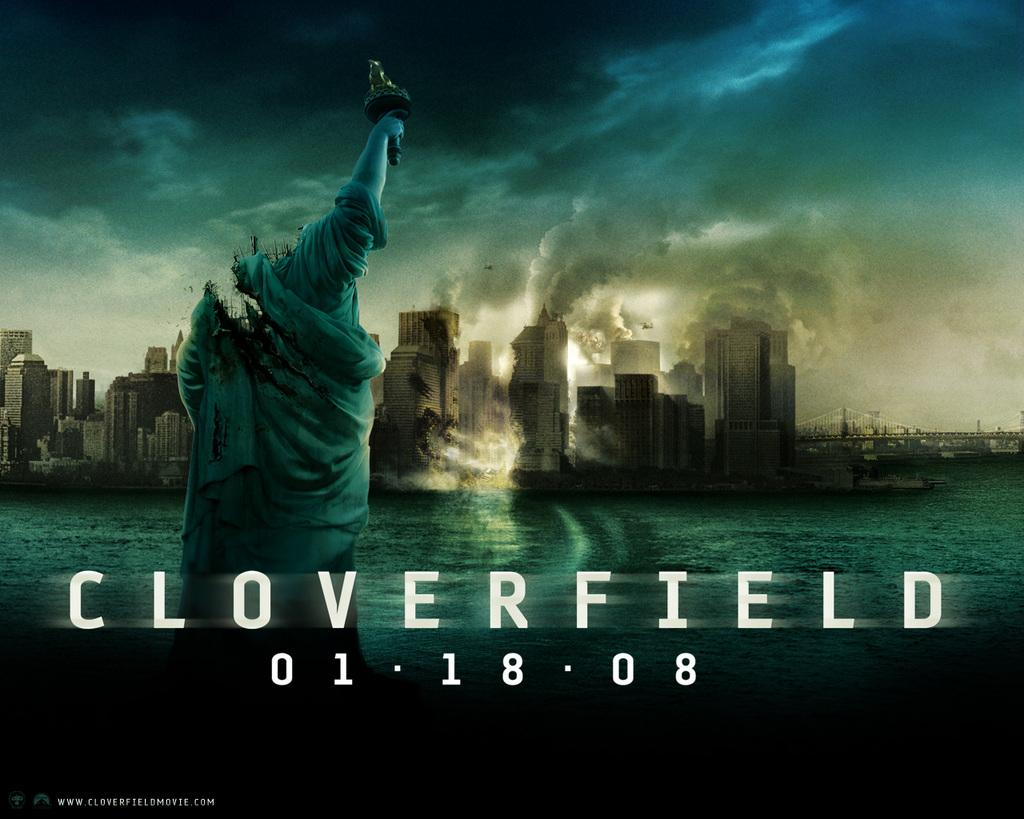<image>
Relay a brief, clear account of the picture shown. A statue over water with burning buildings in background and the word cloverfield typed over all. 